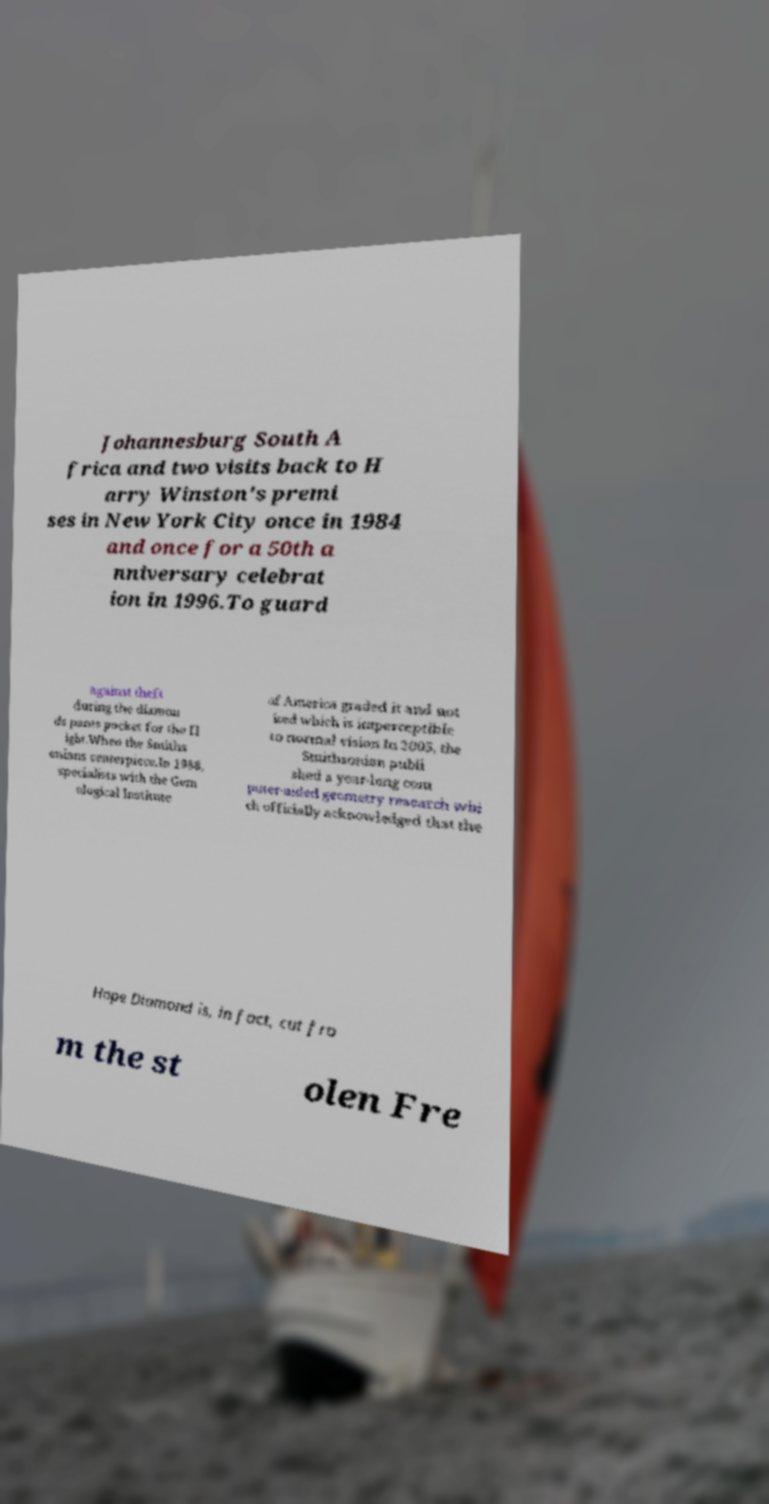Could you extract and type out the text from this image? Johannesburg South A frica and two visits back to H arry Winston's premi ses in New York City once in 1984 and once for a 50th a nniversary celebrat ion in 1996.To guard against theft during the diamon ds pants pocket for the fl ight.When the Smiths onians centerpiece.In 1988, specialists with the Gem ological Institute of America graded it and not iced which is imperceptible to normal vision.In 2005, the Smithsonian publi shed a year-long com puter-aided geometry research whi ch officially acknowledged that the Hope Diamond is, in fact, cut fro m the st olen Fre 